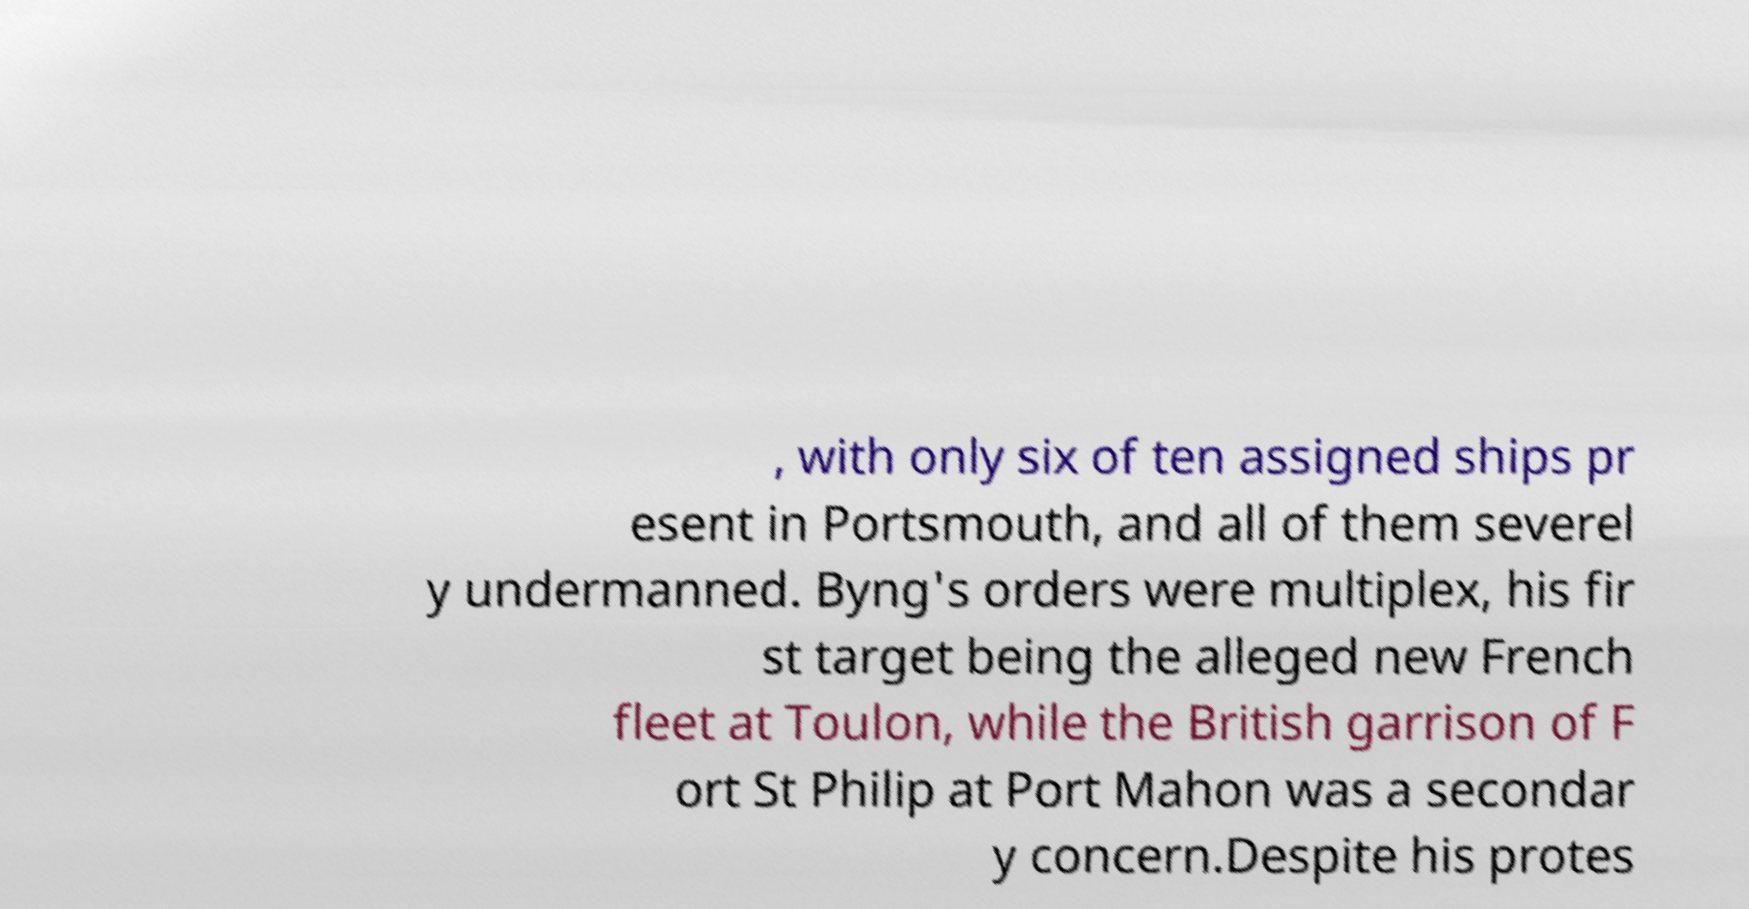What messages or text are displayed in this image? I need them in a readable, typed format. , with only six of ten assigned ships pr esent in Portsmouth, and all of them severel y undermanned. Byng's orders were multiplex, his fir st target being the alleged new French fleet at Toulon, while the British garrison of F ort St Philip at Port Mahon was a secondar y concern.Despite his protes 